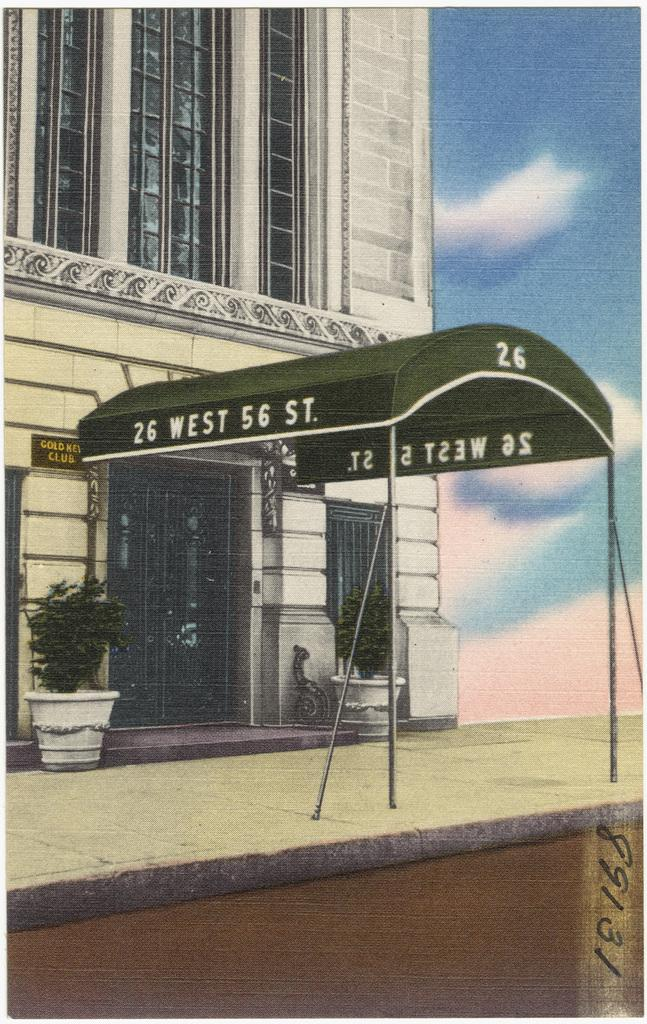What is depicted on the paper in the image? The paper contains a drawing of a building. Are there any additional elements in the drawing? Yes, there are house plants depicted on the paper. What can be seen behind the building in the drawing? There is a sky visible behind the building in the drawing. How many children are shown playing with a key in the image? There are no children or keys present in the image. Can you describe the bite marks on the building in the drawing? There are no bite marks on the building in the drawing; it is a drawing of a building with a sky behind it. 